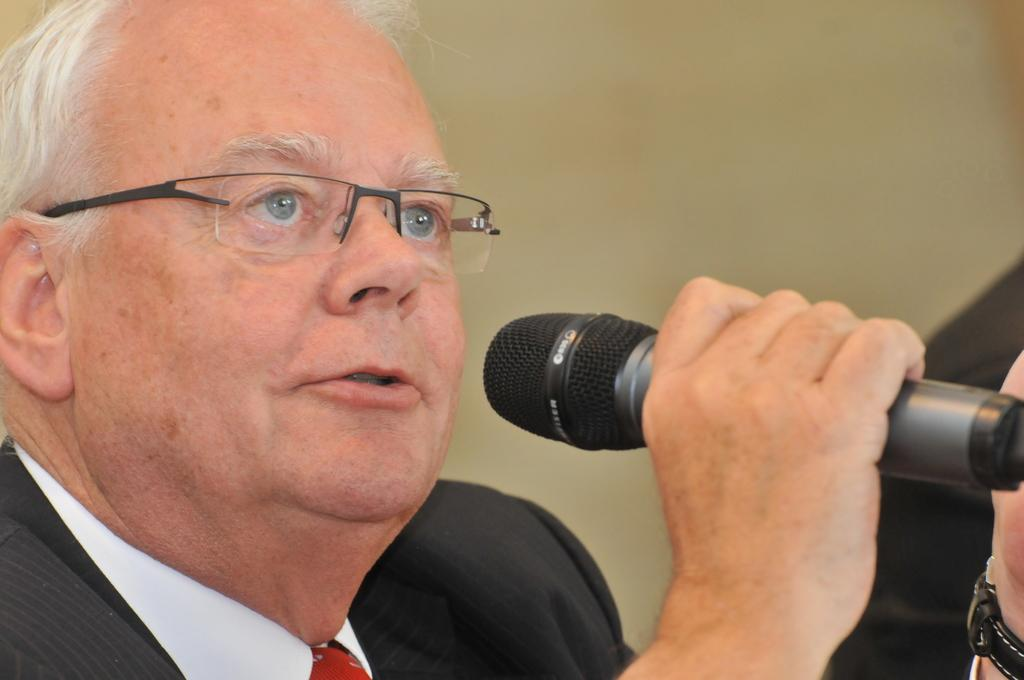What is the person holding in the image? The person is holding a microphone. What is the person doing with the microphone? The person is talking while holding the microphone. Can you describe the person's appearance? The person is wearing glasses and a black color suit. What can be seen in the background of the image? There is a wall in the background. What type of bun is the person eating in the image? There is no bun present in the image; the person is holding a microphone and talking. 